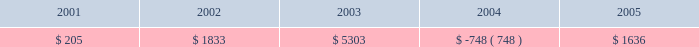For fiscal year 2005 , the effective tax rate includes the impact of $ 11.6 million tax expense associated with repatriation of approximately $ 185.0 million of foreign earnings under the provisions of the american jobs creation act of 2004 .
For fiscal year 2004 , the effective tax rate reflects the tax benefit derived from higher earnings in low-tax jurisdictions .
During fiscal year 2006 , primarily due to a tax accounting method change , there was a decrease of $ 83.2 million in the current deferred tax assets , and a corresponding increase in non-current deferred tax assets .
In the third quarter of fiscal year 2006 , we changed our tax accounting method on our tax return for fiscal year 2005 with respect to the current portion of deferred revenue to follow the recognition of revenue under u.s .
Generally accepted accounting principles .
This accounting method change , as well as other adjustments made to our taxable income upon the filing of the fiscal year 2005 tax return , resulted in an increase in our operating loss ( nol ) carryforwards .
In may 2006 , the tax increase prevention and reconciliation act of 2005 was enacted , which provides a three-year exception to current u.s .
Taxation of certain foreign intercompany income .
This provision will first apply to synopsys in fiscal year 2007 .
Management estimates that had such provisions been applied for fiscal 2006 , our income tax expense would have been reduced by approximately $ 3 million .
In december 2006 , the tax relief and health care act of 2006 was enacted , which retroactively extended the research and development credit from january 1 , 2006 .
As a result , we will record an expected increase in our fiscal 2006 research and development credit of between $ 1.5 million and $ 1.8 million in the first quarter of fiscal 2007 .
Revision of prior year financial statements .
As part of our remediation of the material weakness in internal control over financial reporting identified in fiscal 2005 relating to accounting for income taxes we implemented additional internal control and review procedures .
Through such procedures , in the fourth quarter of fiscal 2006 , we identified four errors totaling $ 8.2 million which affected our income tax provision in fiscal years 2001 through 2005 .
We concluded that these errors were not material to any prior year financial statements .
Although the errors are not material to prior periods , we elected to revise prior year financial statements to correct such errors .
The fiscal periods in which the errors originated , and the resulting change in provision ( benefit ) for income taxes for each year , are reflected in the table : year ended october 31 ( in thousands ) .
The errors were as follows : ( 1 ) synopsys inadvertently provided a $ 1.4 million tax benefit for the write- off of goodwill relating to an acquisition in fiscal 2002 ; ( 2 ) synopsys did not accrue interest and penalties for certain foreign tax contingency items in the amount of $ 3.2 million ; ( 3 ) synopsys made certain computational errors relating to foreign dividends of $ 2.3 million ; and ( 4 ) synopsys did not record a valuation allowance relating to certain state tax credits of $ 1.3 million .
As result of this revision , non-current deferred tax assets decreased by $ 8.1 million and current taxes payable increased by $ 0.2 million .
Retained earnings decreased by $ 8.2 million and additional paid in capital decreased by $ 0.1 million .
See item 9a .
Controls and procedures for a further discussion of our remediation of the material weakness .
Tax effects of stock awards .
In november 2005 , fasb issued a staff position ( fsp ) on fas 123 ( r ) -3 , transition election related to accounting for the tax effects of share-based payment awards .
Effective upon issuance , this fsp describes an alternative transition method for calculating the tax effects of share-based compensation pursuant to sfas 123 ( r ) .
The alternative transition method includes simplified methods to establish the beginning balance of the additional paid-in capital pool ( apic pool ) related to the tax effects of employee stock based compensation , and to determine the subsequent impact on the apic pool and the statement of cash flows of the tax effects of employee share-based compensation .
What is the percentual increase in the resulting change in provision for income taxes caused by errors during 2002 and 2003? 
Rationale: it is the 2003 value divided by the 2002 one then turned into a percentage .
Computations: ((5303 / 1833) - 1)
Answer: 1.89307. 